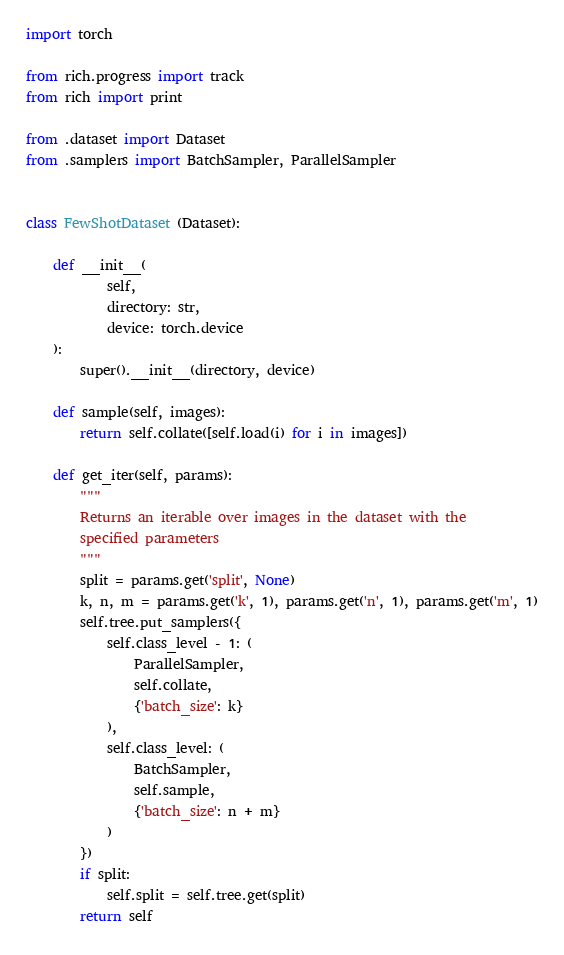<code> <loc_0><loc_0><loc_500><loc_500><_Python_>import torch

from rich.progress import track
from rich import print

from .dataset import Dataset
from .samplers import BatchSampler, ParallelSampler


class FewShotDataset (Dataset):

    def __init__(
            self,
            directory: str,
            device: torch.device
    ):
        super().__init__(directory, device)

    def sample(self, images):
        return self.collate([self.load(i) for i in images])

    def get_iter(self, params):
        """
        Returns an iterable over images in the dataset with the
        specified parameters
        """
        split = params.get('split', None)
        k, n, m = params.get('k', 1), params.get('n', 1), params.get('m', 1)
        self.tree.put_samplers({
            self.class_level - 1: (
                ParallelSampler,
                self.collate,
                {'batch_size': k}
            ),
            self.class_level: (
                BatchSampler,
                self.sample,
                {'batch_size': n + m}
            )
        })
        if split:
            self.split = self.tree.get(split)
        return self
</code> 